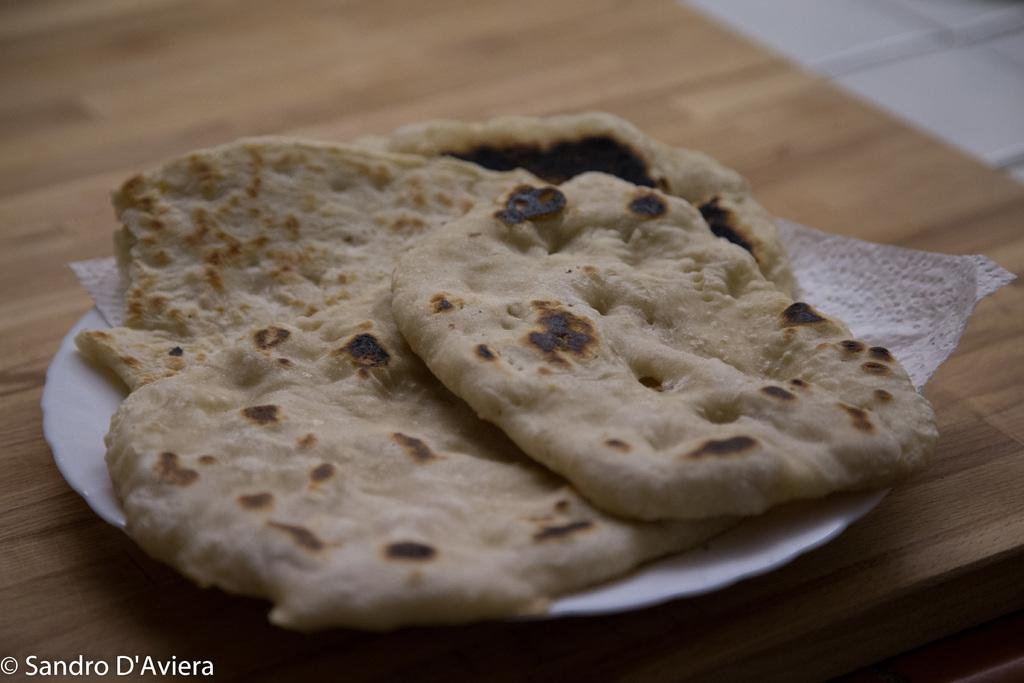What type of food is on the plate in the image? The food appears to be chapatis. Where is the plate with the food located? The plate is on a table. Is there any text visible in the image? Yes, there is text at the bottom left corner of the image. What type of knowledge is being taught in the jail depicted in the image? There is no jail or any indication of knowledge being taught in the image; it features a plate of chapatis on a table with text at the bottom left corner. 